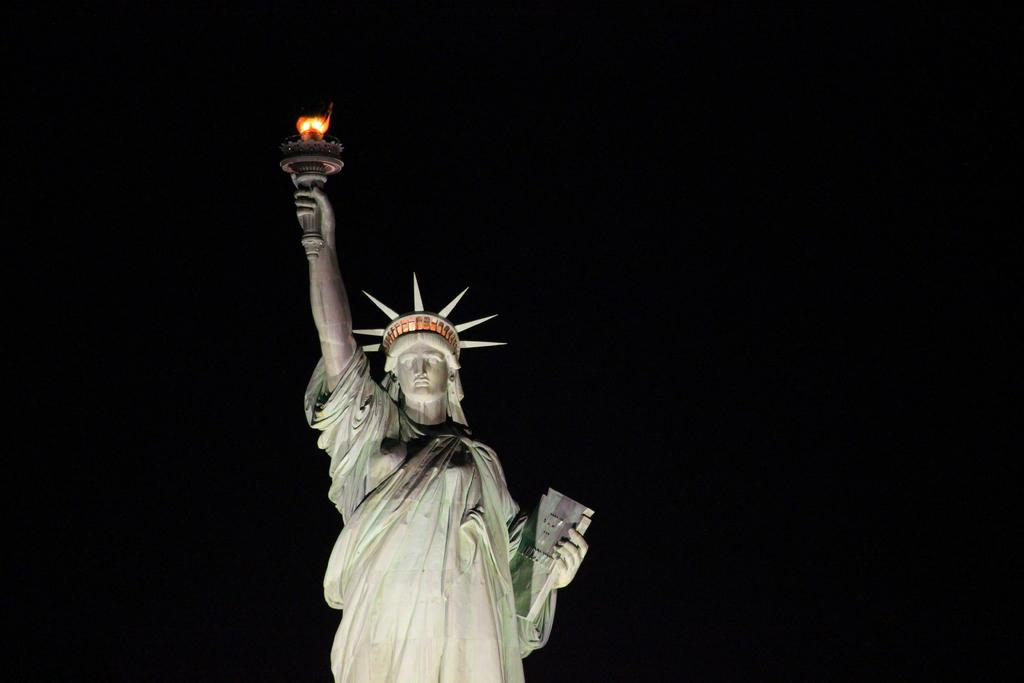What is the main subject of the image? The main subject of the image is the Statue of Liberty. What color is the Statue of Liberty in the image? The Statue of Liberty is in white color. Are there any additional features on the Statue of Liberty in the image? Yes, there is a light on the Statue of Liberty. What type of zephyr can be seen flying around the Statue of Liberty in the image? There is no zephyr present in the image; it is a statue and not a living creature. 